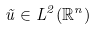<formula> <loc_0><loc_0><loc_500><loc_500>\tilde { u } \in L ^ { 2 } ( \mathbb { R } ^ { n } )</formula> 